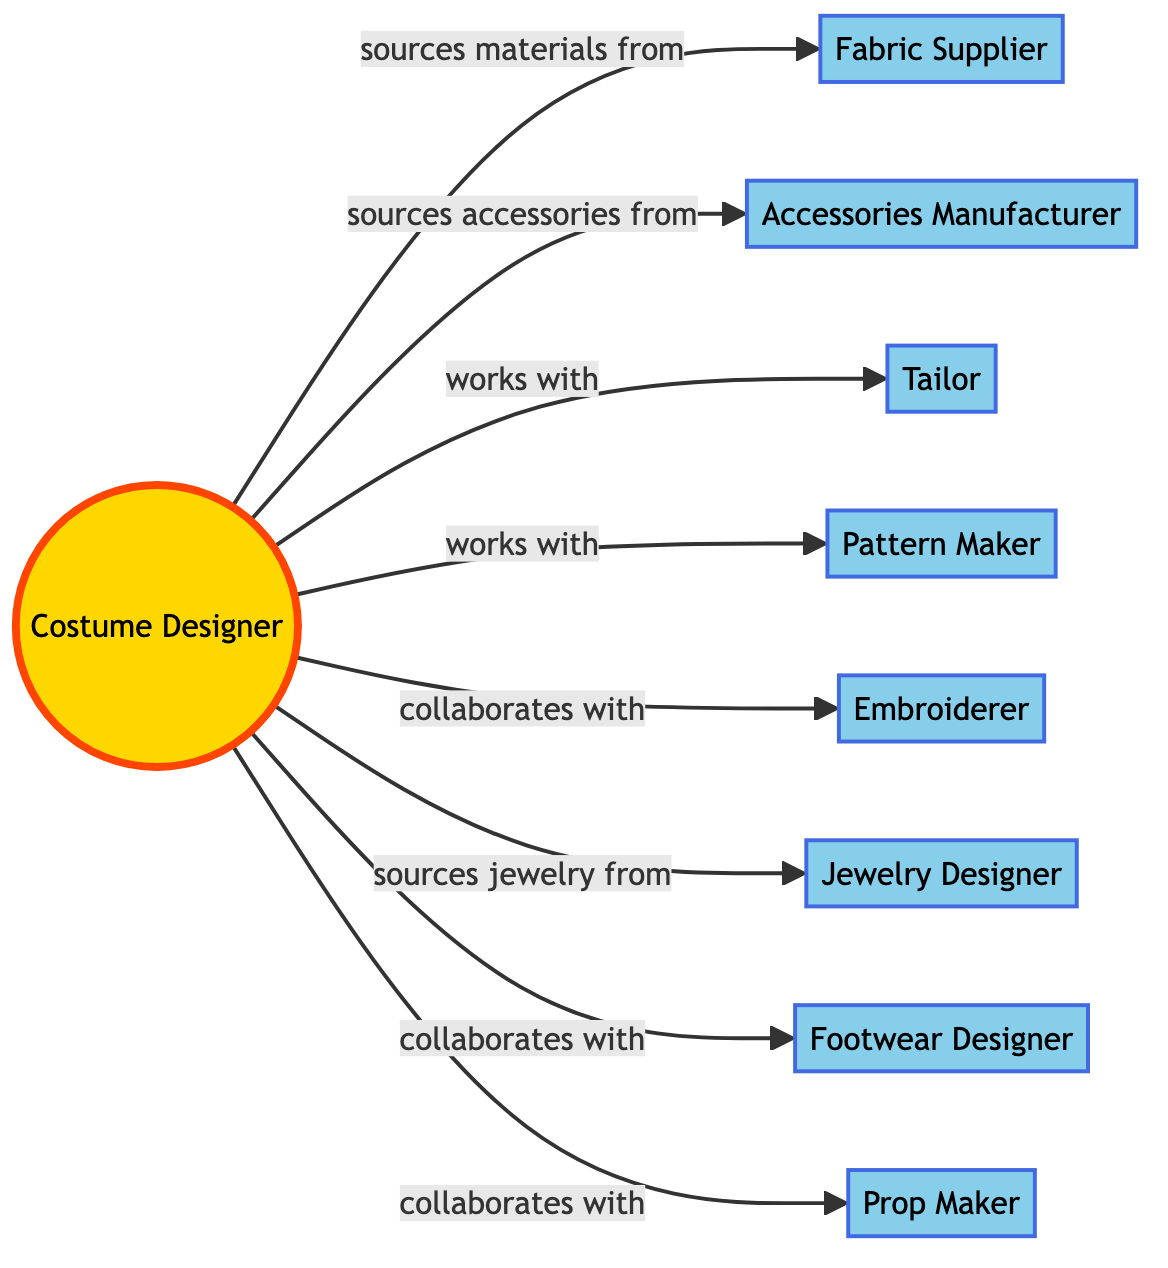What is the central role in this network? The central node in the diagram is the "Costume Designer," as it connects with all other roles in the network, illustrating its importance in the design and production of Elvis Presley outfits.
Answer: Costume Designer How many collaborators are involved in this network? Counting all the nodes apart from the central role (Costume Designer), there are eight collaborators providing different services, leading to a total of nine nodes in the network when including the Costume Designer.
Answer: 8 Which role sources materials from Gold & Glitter Fabrics Inc.? The "Costume Designer" is shown to have a direct connection to Gold & Glitter Fabrics Inc. through the labeled edge "sources materials from," establishing that the designer is responsible for obtaining materials for the outfits.
Answer: Costume Designer How many edges are connected to the Costume Designer? The Costume Designer has eight edges connecting to other nodes in the network, indicating the various roles and collaborations involved in the design and production process.
Answer: 8 Which role collaborates with the Embroiderer? The diagram indicates that the "Costume Designer" collaborates with the "Embroiderer," suggesting a direct working relationship for the embroidery aspect of the outfit design.
Answer: Costume Designer What type of relationship does the Costume Designer have with the Accessories Manufacturer? The relationship is categorized as "sources accessories from," which implies that the Costume Designer relies on the Accessories Manufacturer for specific accessories needed for outfit design.
Answer: sources accessories from Which collaborator is associated with the creation of props? The "Prop Maker" is identified in the diagram as the collaborator responsible for prop creation, highlighting a specific area of collaboration necessary for costume production.
Answer: Prop Maker How many different types of collaborators are represented in the diagram? The diagram displays various roles, specifically: Material Provider, Accessory Provider, Garment Construction, Pattern Designer, Embroidery Specialist, Jewelry Provider, Shoe Designer, and Prop Creation, which sums to eight distinct types of collaborators involved in the process.
Answer: 8 Which node sources jewelry from Elvis King Accessories? The relationship labeled as "sources jewelry from" indicates that the "Costume Designer" is the node that sources jewelry from Elvis King Accessories, stipulating the supply chain for jewelry in the outfits.
Answer: Costume Designer 